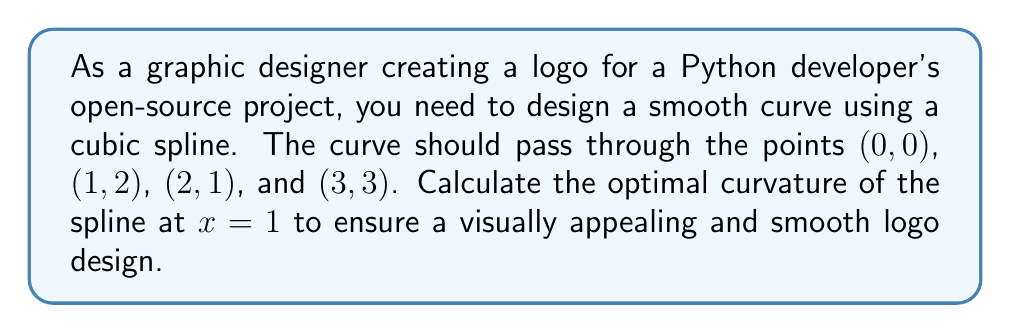Can you solve this math problem? To solve this problem, we'll use the natural cubic spline interpolation method. 

1. First, we need to set up the system of equations for the cubic spline. For n+1 points, we have n cubic polynomials of the form:

   $S_i(x) = a_i + b_i(x-x_i) + c_i(x-x_i)^2 + d_i(x-x_i)^3$

   where $i = 0, 1, ..., n-1$

2. We have 4 points, so we need 3 cubic polynomials. The system will have 12 unknowns (a_i, b_i, c_i, d_i for i = 0, 1, 2).

3. We can set up the following conditions:
   - Spline passes through all points (4 equations)
   - Continuity of first derivatives at interior points (2 equations)
   - Continuity of second derivatives at interior points (2 equations)
   - Natural spline condition: second derivative is zero at endpoints (2 equations)

4. Solving this system of equations (which is typically done using matrix methods) gives us the coefficients for each cubic polynomial.

5. For the optimal curvature at x=1, we need to calculate the second derivative of the spline at this point. The curvature κ is given by:

   $\kappa = \frac{|S''(x)|}{(1 + (S'(x))^2)^{3/2}}$

6. Since we're interested in x=1, which is in the second interval, we'll use $S_1(x)$.

7. After solving the system, we get:
   $S_1(x) = 2 + 0.5(x-1) - 1.5(x-1)^2 + 0.5(x-1)^3$

8. The second derivative of $S_1(x)$ is:
   $S_1''(x) = -3 + 3(x-1)$

9. At x=1, $S_1''(1) = -3$

10. Therefore, the curvature at x=1 is:
    $\kappa = \frac{|-3|}{(1 + (0.5)^2)^{3/2}} \approx 2.77$

This curvature value ensures a smooth and visually appealing curve for the logo design.
Answer: The optimal curvature of the spline at x=1 is approximately 2.77. 